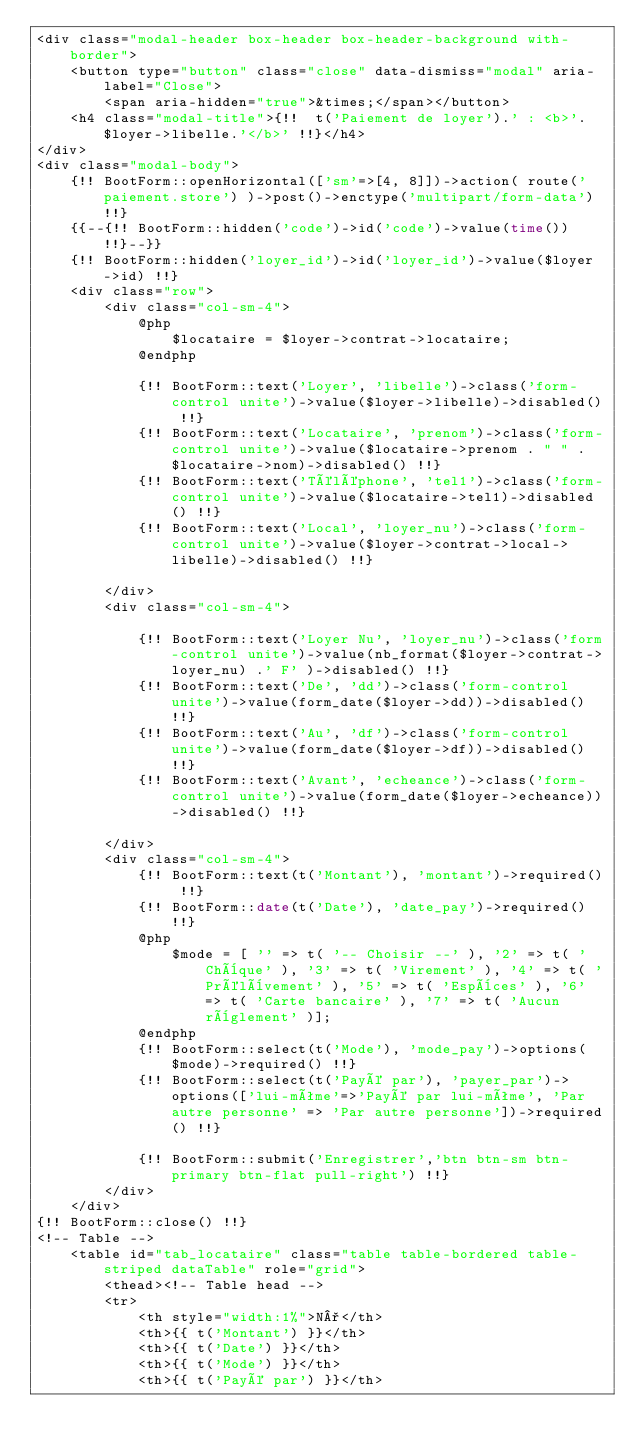Convert code to text. <code><loc_0><loc_0><loc_500><loc_500><_PHP_><div class="modal-header box-header box-header-background with-border">
    <button type="button" class="close" data-dismiss="modal" aria-label="Close">
        <span aria-hidden="true">&times;</span></button>
    <h4 class="modal-title">{!!  t('Paiement de loyer').' : <b>'.$loyer->libelle.'</b>' !!}</h4>
</div>
<div class="modal-body">
    {!! BootForm::openHorizontal(['sm'=>[4, 8]])->action( route('paiement.store') )->post()->enctype('multipart/form-data') !!}
    {{--{!! BootForm::hidden('code')->id('code')->value(time()) !!}--}}
    {!! BootForm::hidden('loyer_id')->id('loyer_id')->value($loyer->id) !!}
    <div class="row">
        <div class="col-sm-4">
            @php
                $locataire = $loyer->contrat->locataire;
            @endphp

            {!! BootForm::text('Loyer', 'libelle')->class('form-control unite')->value($loyer->libelle)->disabled() !!}
            {!! BootForm::text('Locataire', 'prenom')->class('form-control unite')->value($locataire->prenom . " " . $locataire->nom)->disabled() !!}
            {!! BootForm::text('Téléphone', 'tel1')->class('form-control unite')->value($locataire->tel1)->disabled() !!}
            {!! BootForm::text('Local', 'loyer_nu')->class('form-control unite')->value($loyer->contrat->local->libelle)->disabled() !!}

        </div>
        <div class="col-sm-4">

            {!! BootForm::text('Loyer Nu', 'loyer_nu')->class('form-control unite')->value(nb_format($loyer->contrat->loyer_nu) .' F' )->disabled() !!}
            {!! BootForm::text('De', 'dd')->class('form-control unite')->value(form_date($loyer->dd))->disabled() !!}
            {!! BootForm::text('Au', 'df')->class('form-control unite')->value(form_date($loyer->df))->disabled() !!}
            {!! BootForm::text('Avant', 'echeance')->class('form-control unite')->value(form_date($loyer->echeance))->disabled() !!}

        </div>
        <div class="col-sm-4">
            {!! BootForm::text(t('Montant'), 'montant')->required() !!}
            {!! BootForm::date(t('Date'), 'date_pay')->required() !!}
            @php
                $mode = [ '' => t( '-- Choisir --' ), '2' => t( 'Chèque' ), '3' => t( 'Virement' ), '4' => t( 'Prélèvement' ), '5' => t( 'Espèces' ), '6' => t( 'Carte bancaire' ), '7' => t( 'Aucun règlement' )];
            @endphp
            {!! BootForm::select(t('Mode'), 'mode_pay')->options($mode)->required() !!}
            {!! BootForm::select(t('Payé par'), 'payer_par')->options(['lui-même'=>'Payé par lui-même', 'Par autre personne' => 'Par autre personne'])->required() !!}

            {!! BootForm::submit('Enregistrer','btn btn-sm btn-primary btn-flat pull-right') !!}
        </div>
    </div>
{!! BootForm::close() !!}
<!-- Table -->
    <table id="tab_locataire" class="table table-bordered table-striped dataTable" role="grid">
        <thead><!-- Table head -->
        <tr>
            <th style="width:1%">N°</th>
            <th>{{ t('Montant') }}</th>
            <th>{{ t('Date') }}</th>
            <th>{{ t('Mode') }}</th>
            <th>{{ t('Payé par') }}</th></code> 